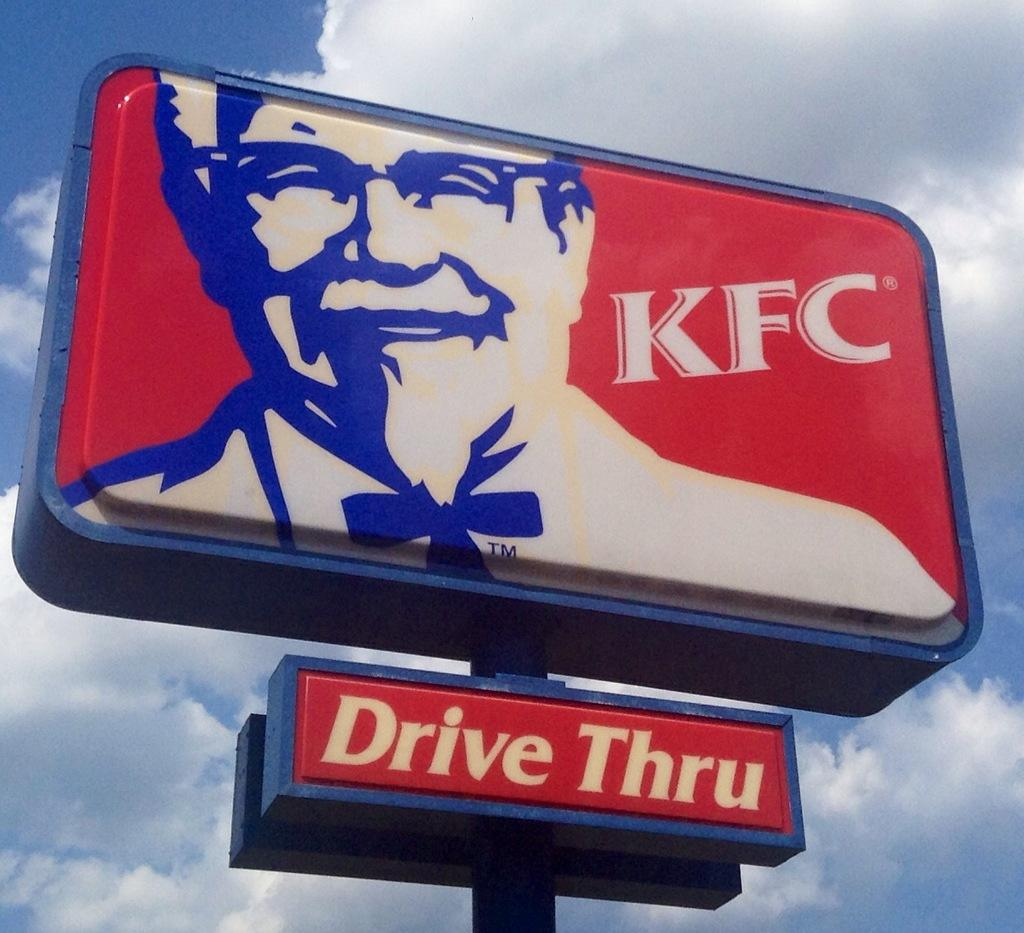Provide a one-sentence caption for the provided image. Blue and red sign that says Drive Thru on it. 